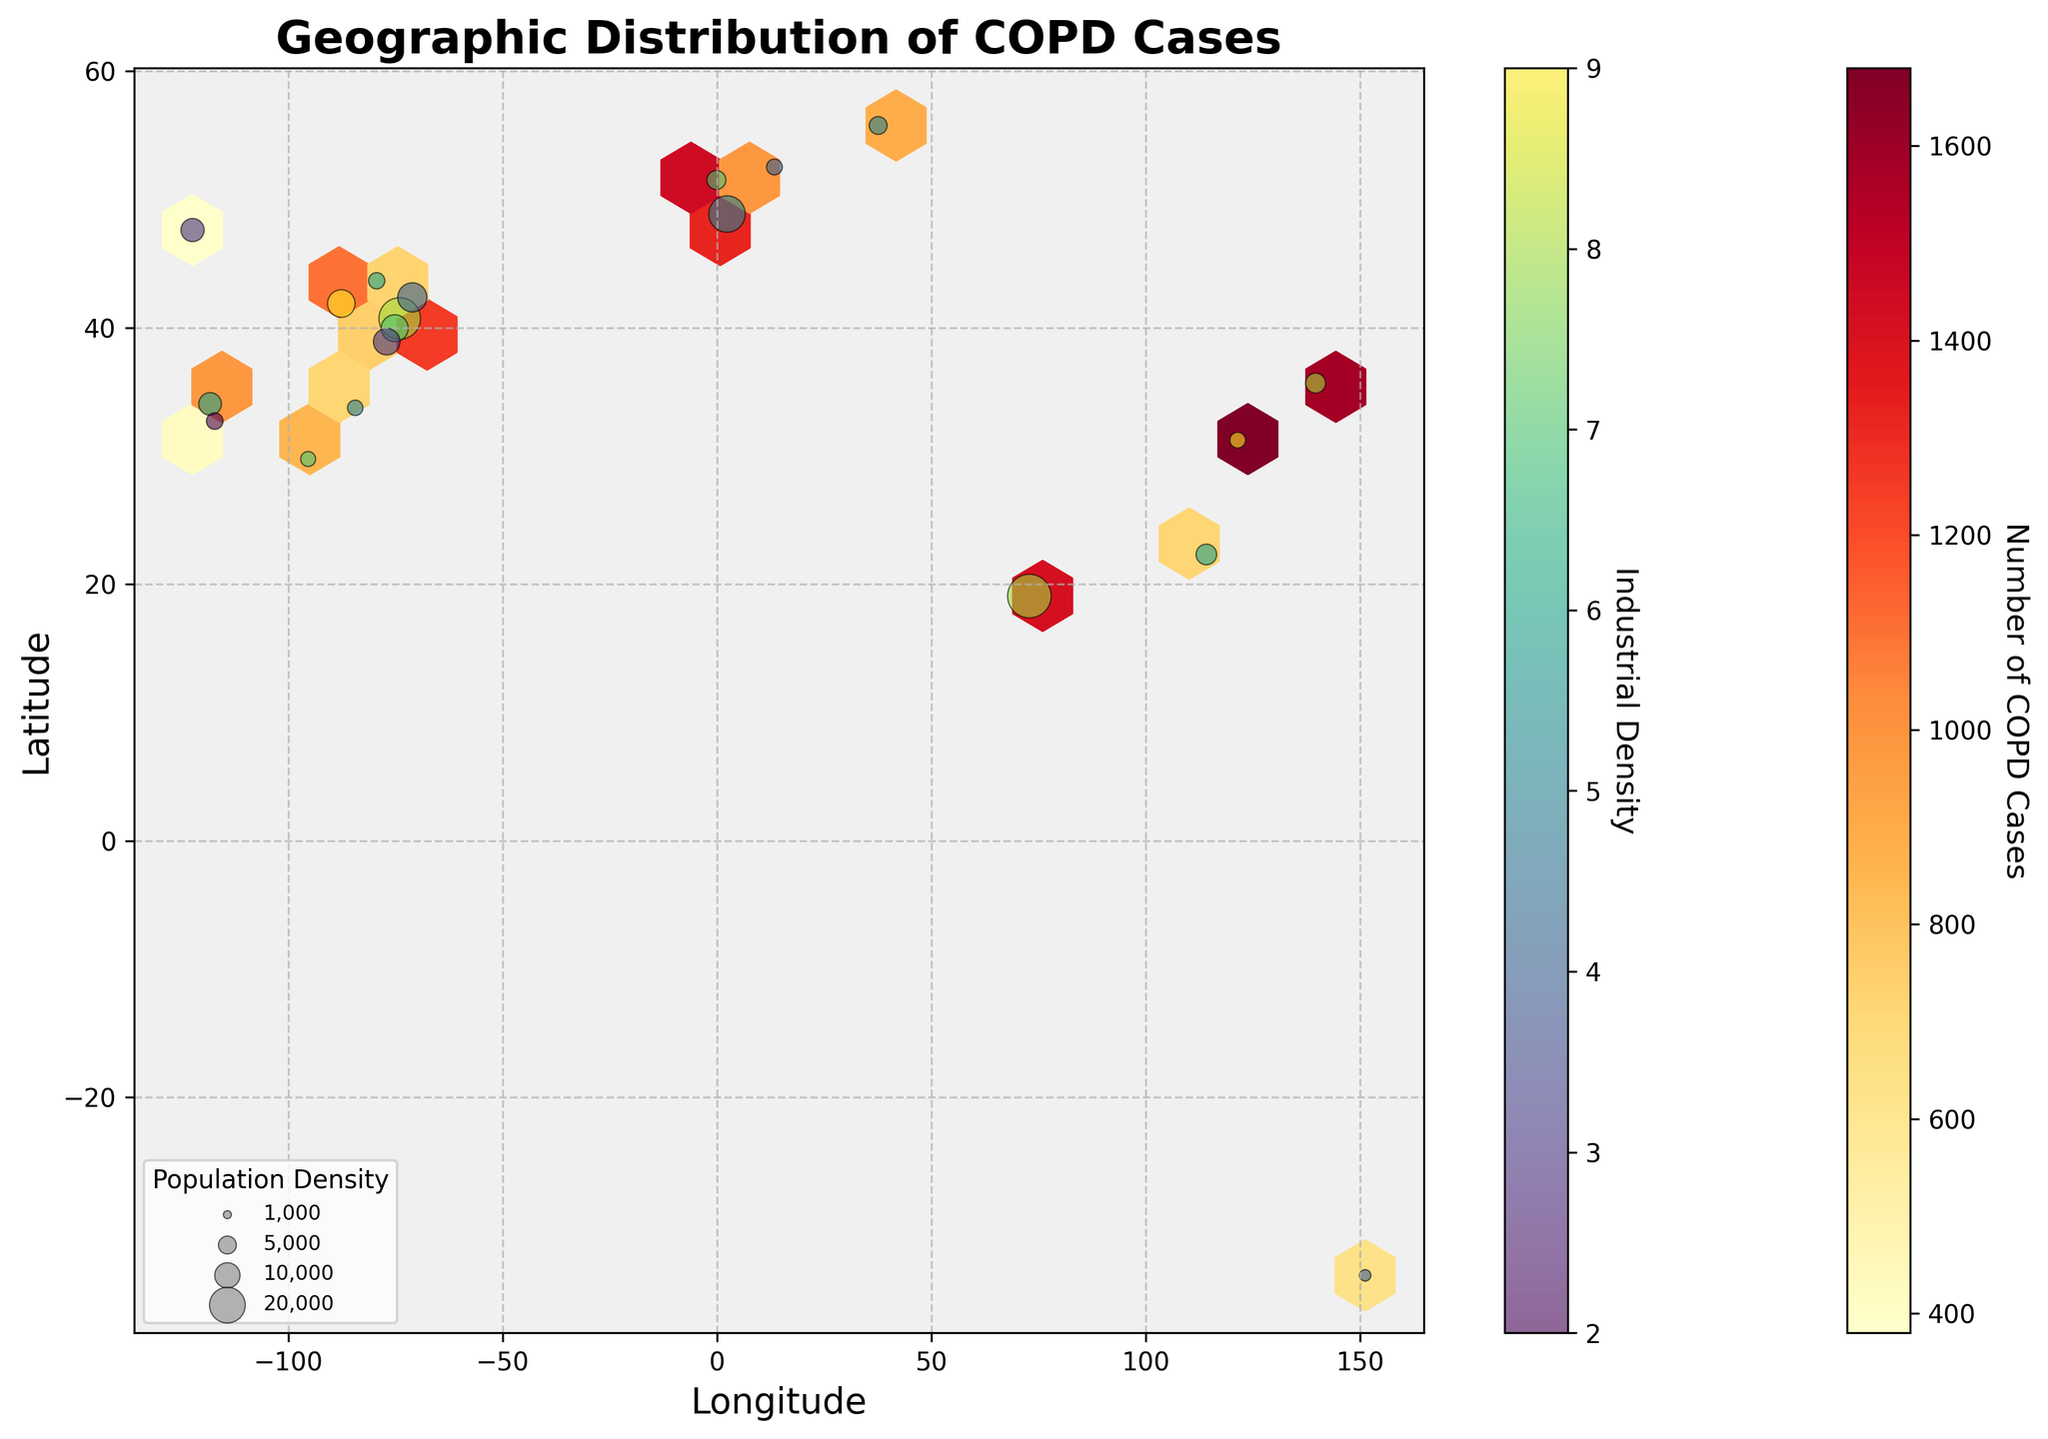What is the title of the plot? The title of the plot is displayed at the top of the figure. It reads "Geographic Distribution of COPD Cases".
Answer: Geographic Distribution of COPD Cases What units are the x and y axes labeled in? The x-axis is labeled "Longitude" and the y-axis is labeled "Latitude", which are units of geographic coordinates.
Answer: Longitude and Latitude Which city appears to have the highest number of COPD cases? Based on the color intensity of the hexbin plot, New York City (located around the coordinates 40.7128, -74.0060) has the highest intensity, indicating the highest number of COPD cases.
Answer: New York City Is there a city with a low number of COPD cases but high industrial density? If so, which one? By examining the scatter plot on top of the hexbin plot, San Diego (located around 32.7157, -117.1611) has low color intensity indicating lower COPD cases but the color of the scatter point indicates relatively high industrial density.
Answer: San Diego Do high population density areas correlate with high COPD cases? Cities with high population density, such as New York City and Mumbai (around coordinates 19.0760, 72.8777), appear to also have high COPD cases, suggesting a positive correlation between population density and COPD cases.
Answer: Yes Which city has the highest industrial density apart from New York City? By looking at the color spectrum of the scatter points, Shanghai (located around 31.2304, 121.4737) has one of the highest industrial densities indicated by its color, other than New York City.
Answer: Shanghai Do areas with high industrial density also have high COPD cases? The hexbin plot combined with scatter points indicate areas like New York City, Chicago, and Shanghai have both high industrial density and high COPD cases, indicating a potential correlation.
Answer: Yes How does the population density of Tokyo compare to that of Paris? Tokyo (around 35.6762, 139.6503) has a population density indicated by a moderately sized scatter point, whereas Paris (around 48.8566, 2.3522) has a larger scatter point, indicating Paris has a higher population density.
Answer: Paris has higher population density Is there variability in industrial density among the cities with the lowest COPD cases? For cities like Seattle (around 47.6062, -122.3321) and San Diego (around 32.7157, -117.1611) that have low COPD cases, the scatter points show different colors, indicating variability in industrial density.
Answer: Yes Are there any cities with both low COPD cases and low industrial density? Based on the plot, Seattle (located around 47.6062, -122.3321) shows both low COPD cases and low industrial density, indicated by a low-intensity hexbin and a light-colored scatter point.
Answer: Seattle 